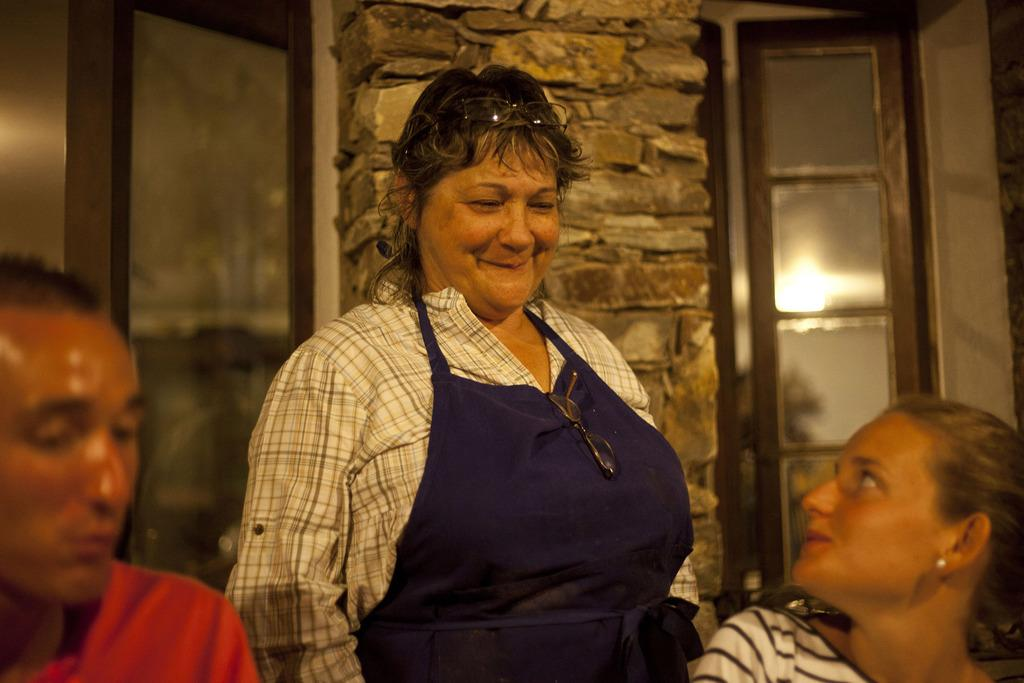How many people are in the image? There are three people in the image. Can you describe the gender of the people in the image? Two of the people are women. What is the facial expression of one of the women? One of the women is smiling. What can be seen in the background of the image? There is a pillar in the background of the image. What type of canvas is being used by the secretary in the image? There is no secretary or canvas present in the image. 